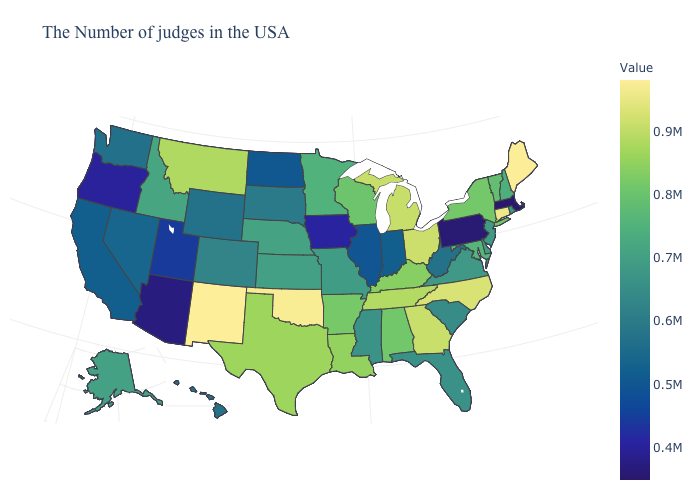Does Utah have the highest value in the West?
Answer briefly. No. Does Maine have the highest value in the Northeast?
Keep it brief. Yes. Does the map have missing data?
Write a very short answer. No. 